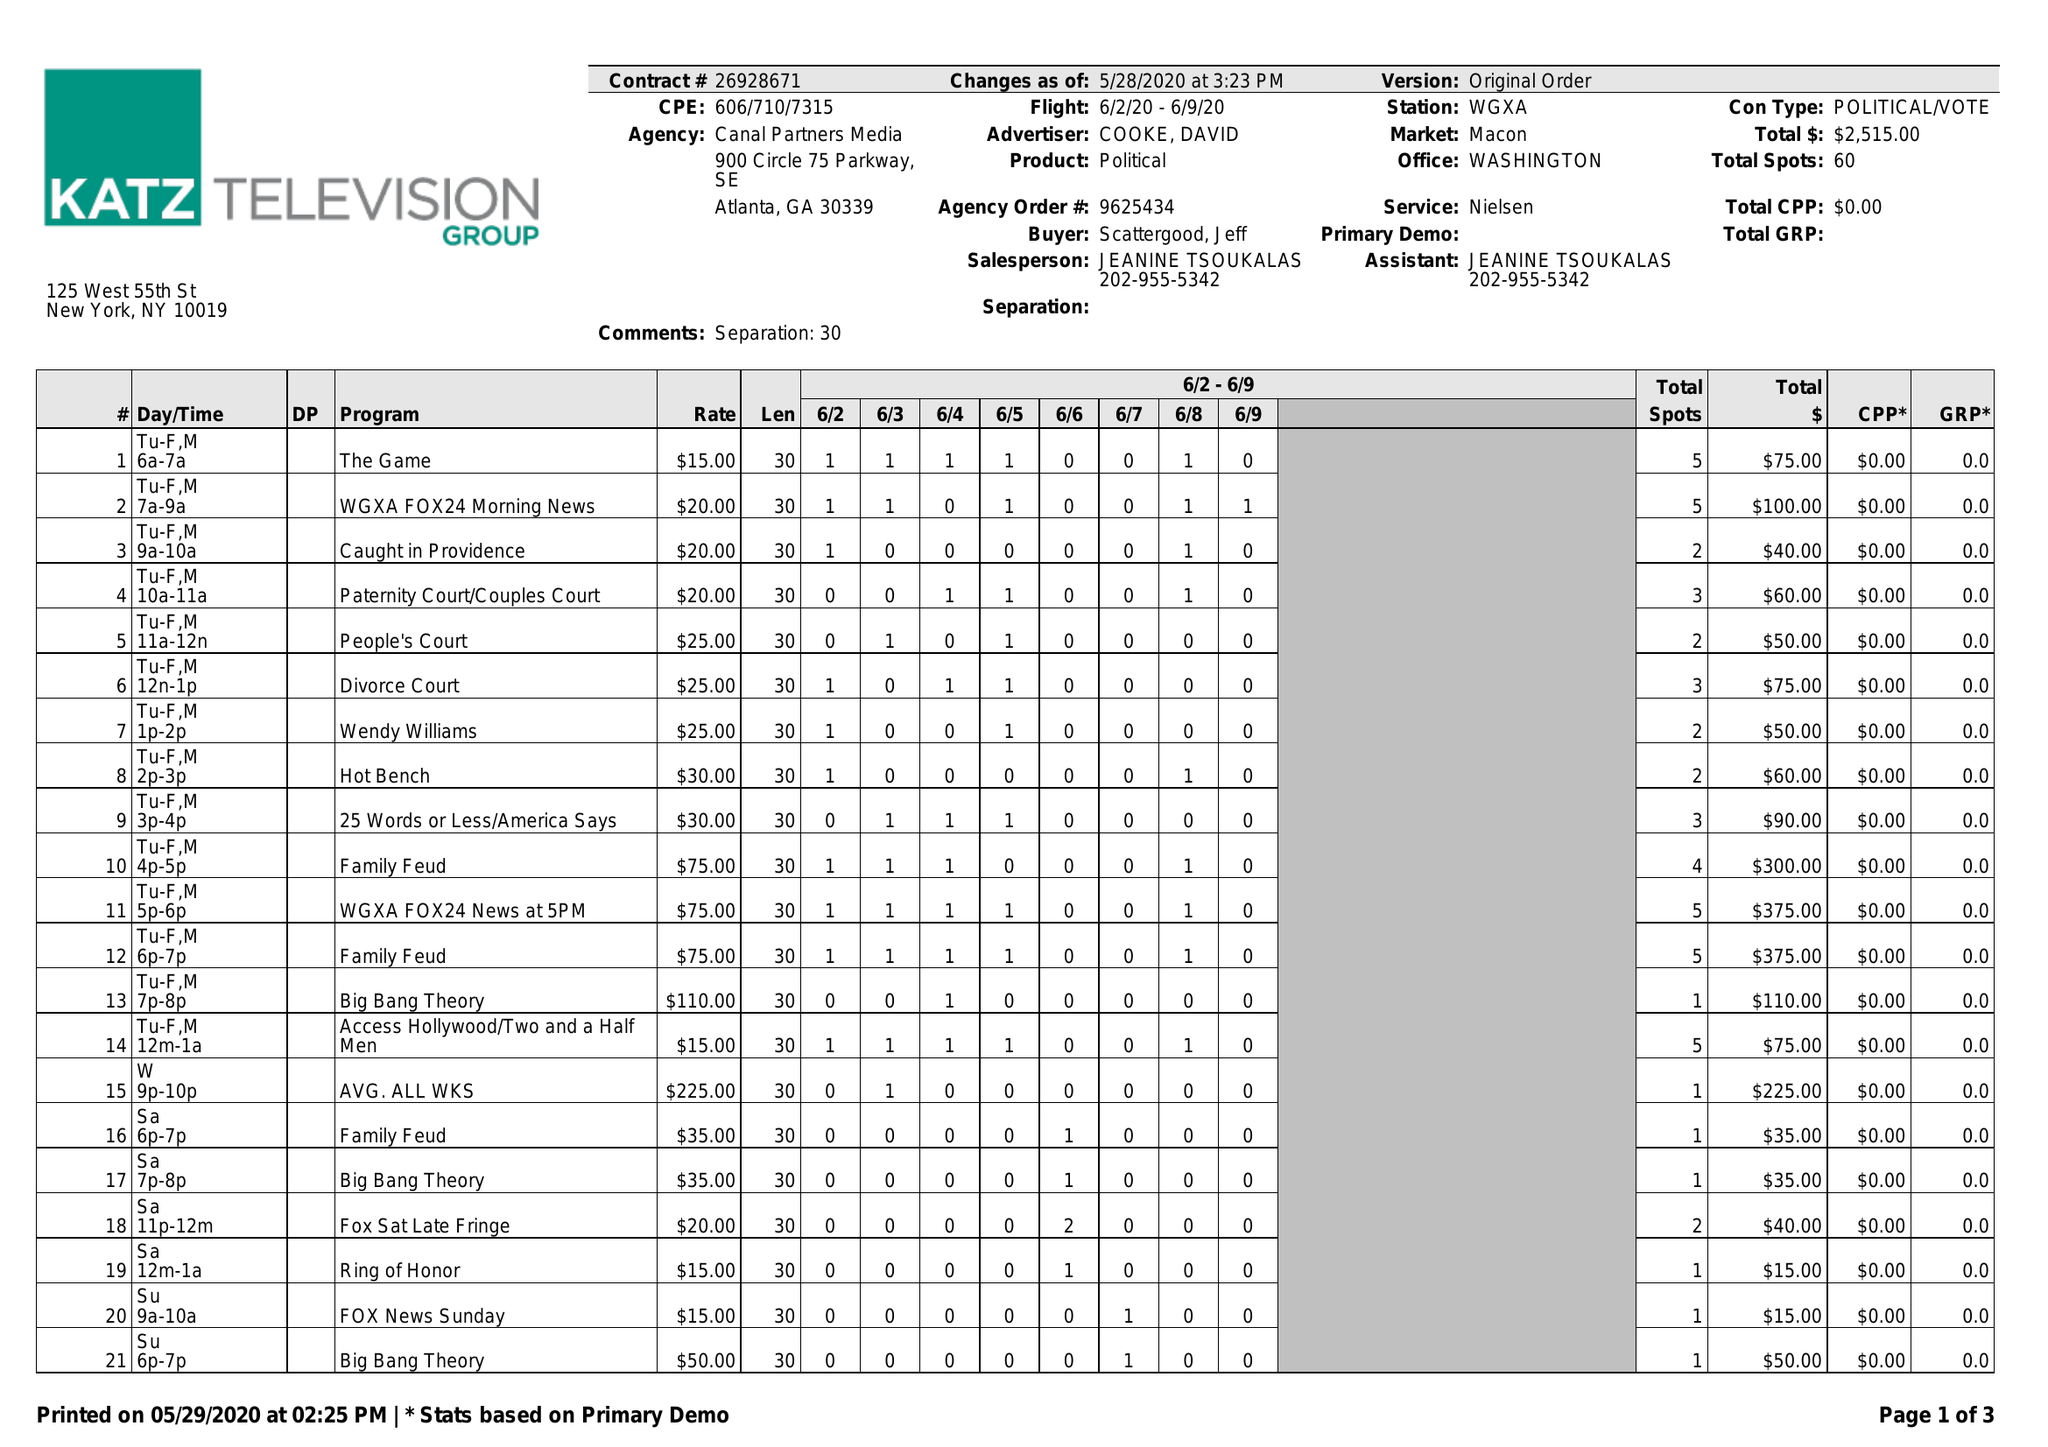What is the value for the advertiser?
Answer the question using a single word or phrase. COOKE, DAVID 